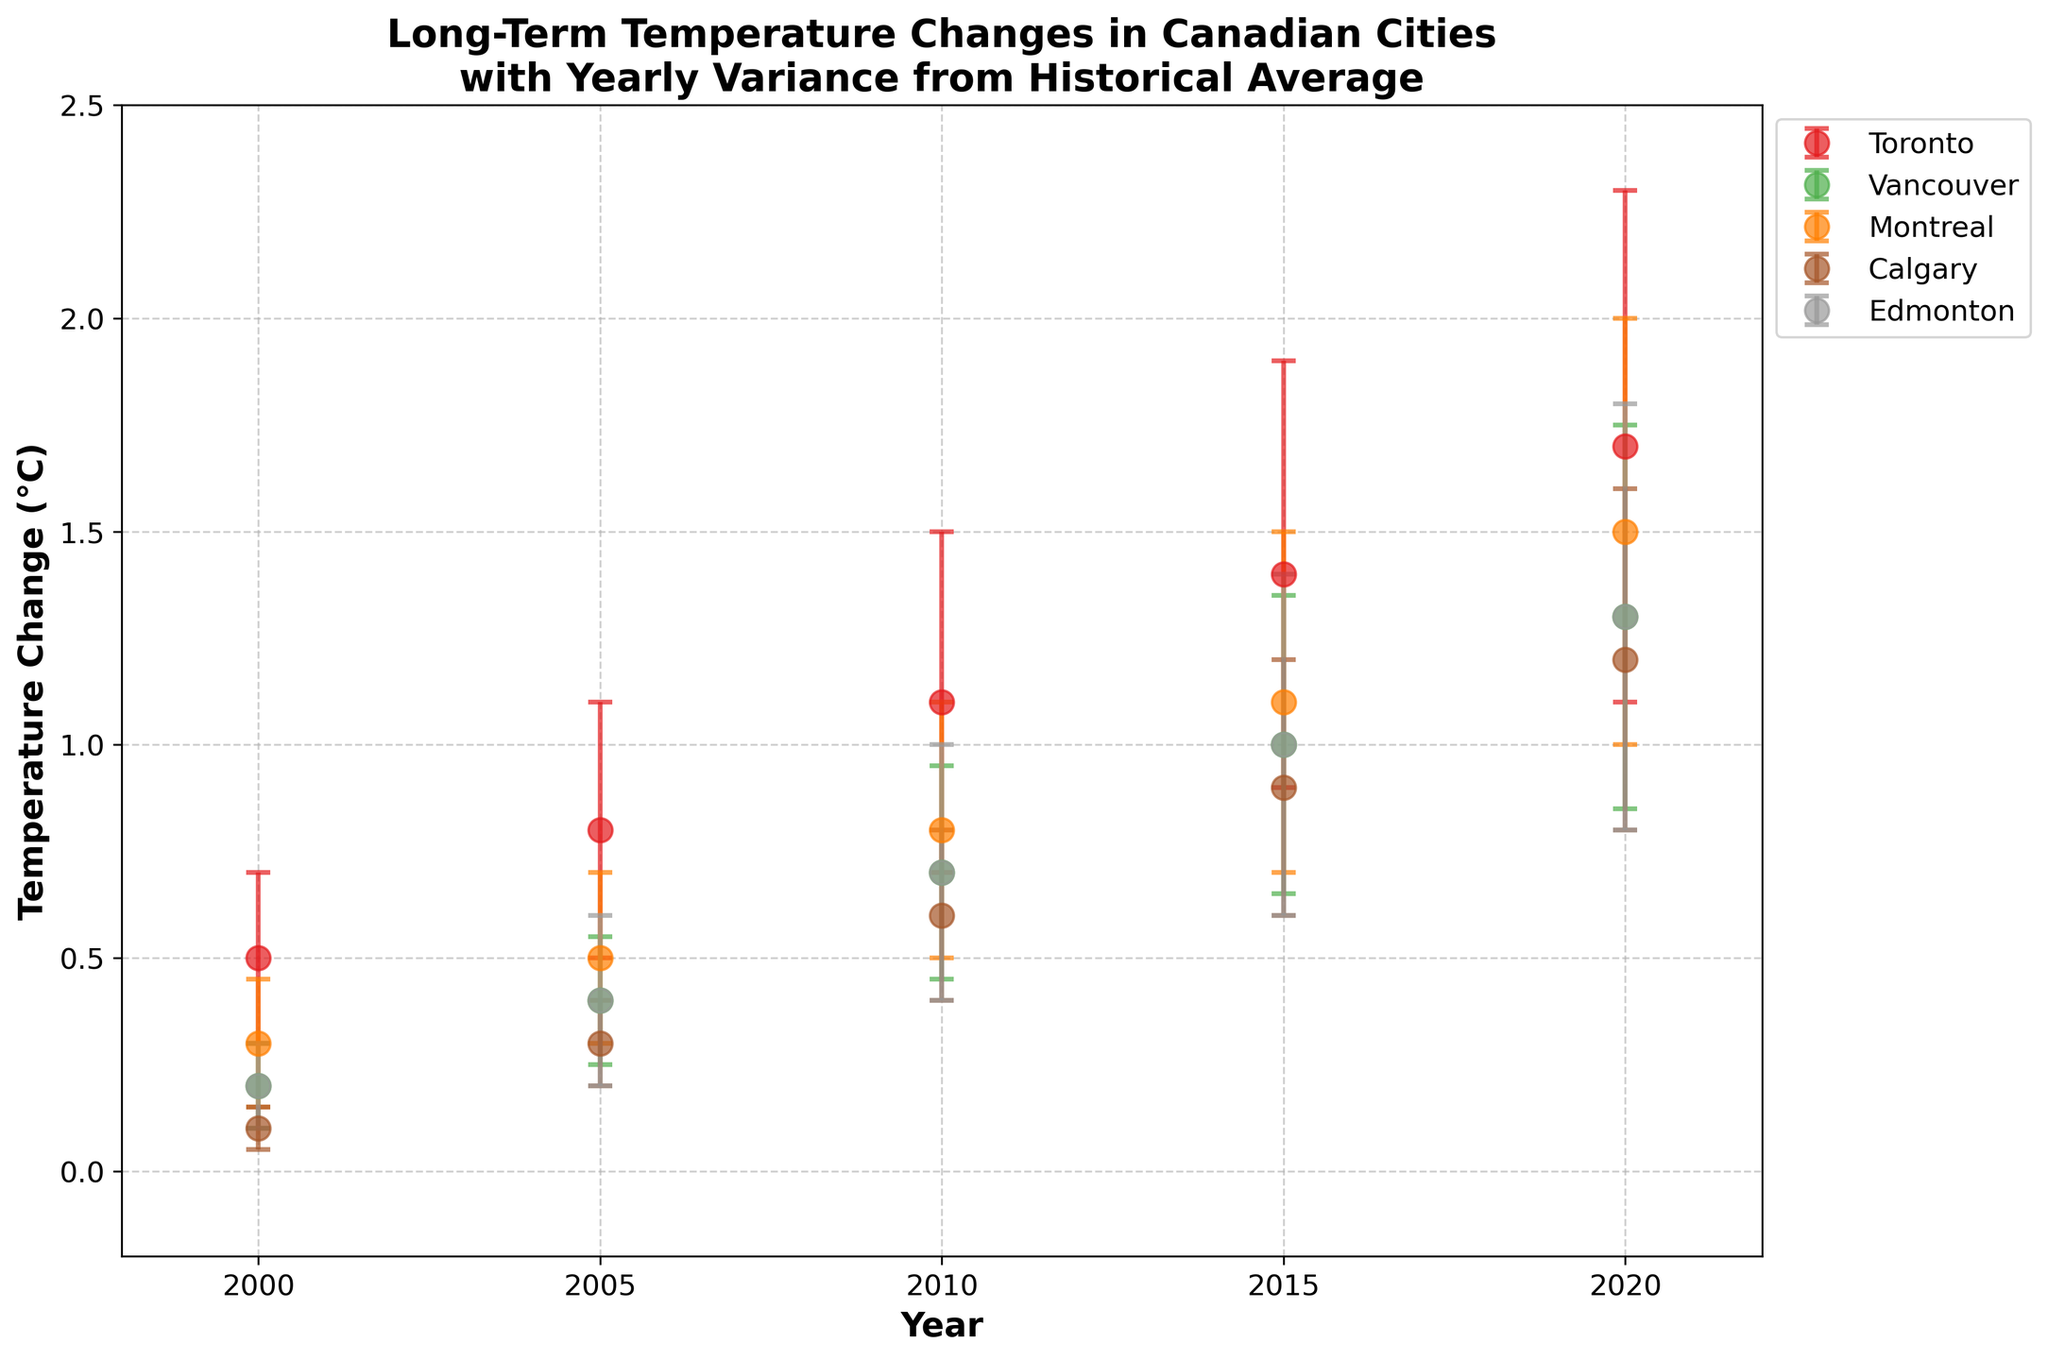What's the title of the figure? The title is typically placed at the top of the figure and it summarizes what the scatter plot with error bars represents. In this case, it points out the geographic region, metric, and the type of variance included.
Answer: Long-Term Temperature Changes in Canadian Cities with Yearly Variance from Historical Average How many cities are displayed in the plot? By looking at the legend on the right side of the plot, you can count the distinct colors and city names listed. Each color and label represent a different city.
Answer: 5 What is the temperature change for Toronto in the year 2010? Locate the 2010 tick on the x-axis, then identify the colored marker that corresponds to Toronto. The y-axis value at that marker indicates the temperature change for the city in that year.
Answer: 1.1°C Which city shows the highest variance in the year 2020? Check the error bars for each city in the year 2020 by looking at the 2020 tick on the x-axis. The length of the error bars indicates the variance, the longer the error bars, the higher the variance.
Answer: Toronto On average, how much did the temperature change for Vancouver from 2000 to 2020? Calculate the average of the temperature change for Vancouver by summing up the changes for each year (2000, 2005, 2010, 2015, 2020) and then divide by the number of years.
Answer: (0.2 + 0.4 + 0.7 + 1.0 + 1.3) / 5 = 0.72°C Which city shows the most significant increase in temperature from 2000 to 2020? For each city, subtract the temperature change in 2000 from the temperature change in 2020. The city with the largest positive difference shows the most significant increase.
Answer: Toronto In which year does Montreal show a temperature change greater than 1°C for the first time? Look at Montreal's markers along the x-axis and find the earliest year where the marker's y-value exceeds 1°C.
Answer: 2015 Which city has the smallest temperature change in 2000? Identify the temperature change values for all the cities in the year 2000 by looking at the markers' y-values along the 2000 tick on the x-axis. The city with the lowest value has the smallest change.
Answer: Calgary Compare the temperature change variance in 2015 between Calgary and Edmonton. Which city had a larger variance? Locate the markers for both cities in the year 2015 on the x-axis and compare the length of their error bars; the city with the longer error bar has the larger variance.
Answer: Edmonton What trend do you observe in the temperature changes for all cities from 2000 to 2020? Look at the overall pattern of the markers on the plot for each city from left (2000) to right (2020) to determine if the temperature changes are increasing, decreasing, or stable over the years.
Answer: Increasing 